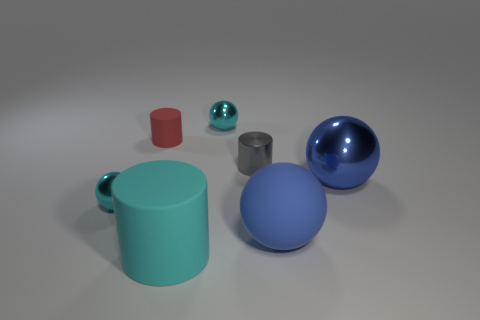Subtract all rubber spheres. How many spheres are left? 3 Subtract all gray spheres. Subtract all brown blocks. How many spheres are left? 4 Add 2 gray metal cylinders. How many objects exist? 9 Subtract all cylinders. How many objects are left? 4 Add 3 gray cylinders. How many gray cylinders exist? 4 Subtract 0 yellow blocks. How many objects are left? 7 Subtract all gray shiny objects. Subtract all shiny cylinders. How many objects are left? 5 Add 5 tiny cyan metal things. How many tiny cyan metal things are left? 7 